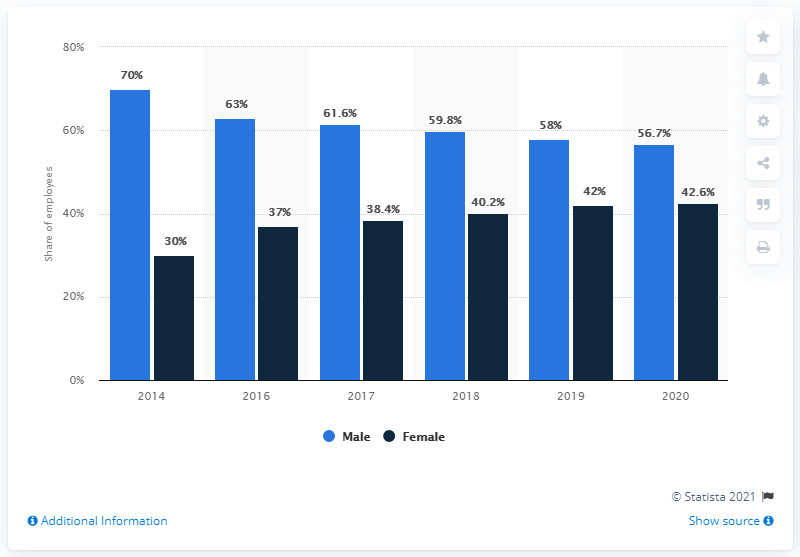Which year saw the smallest difference between the number of male and female employees? In the year 2020, the gender distribution amongst employees reached its closest point, with males at 56.7% and females at 42.6%. This signifies a difference of merely 14.1 percentage points, marking it as the year with the most balanced representation of gender within the observed time frame. 